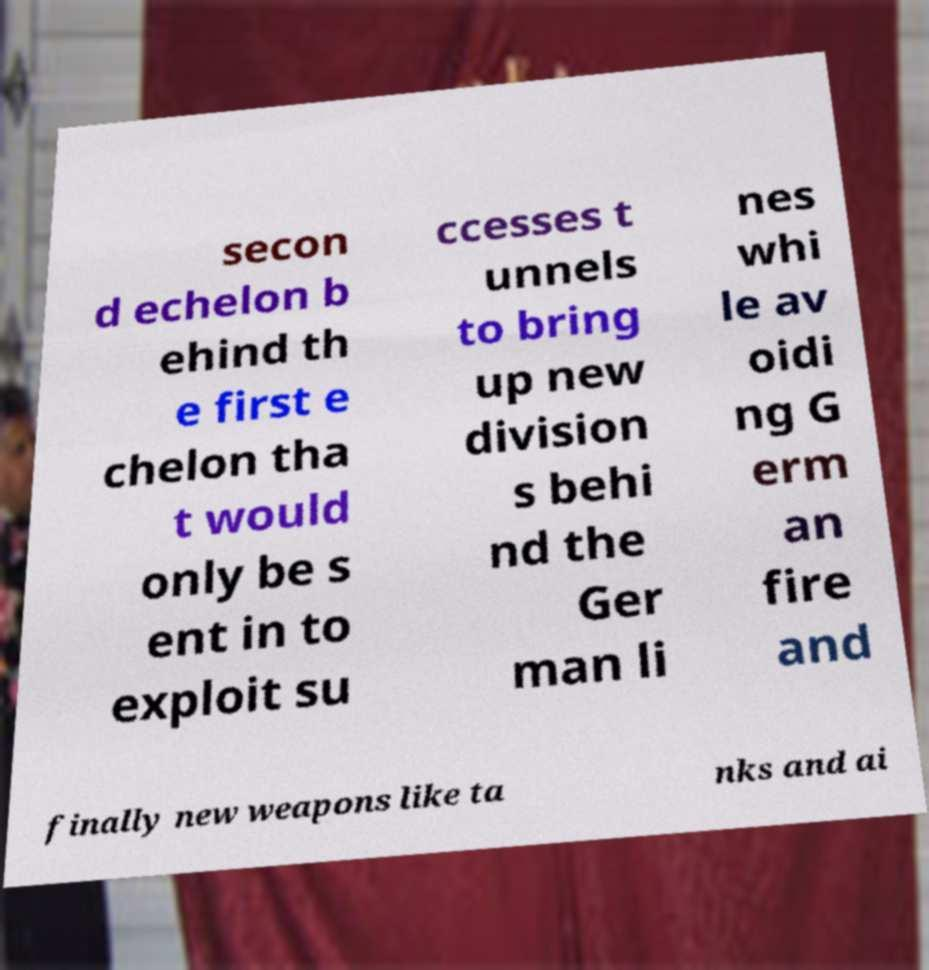Please read and relay the text visible in this image. What does it say? secon d echelon b ehind th e first e chelon tha t would only be s ent in to exploit su ccesses t unnels to bring up new division s behi nd the Ger man li nes whi le av oidi ng G erm an fire and finally new weapons like ta nks and ai 